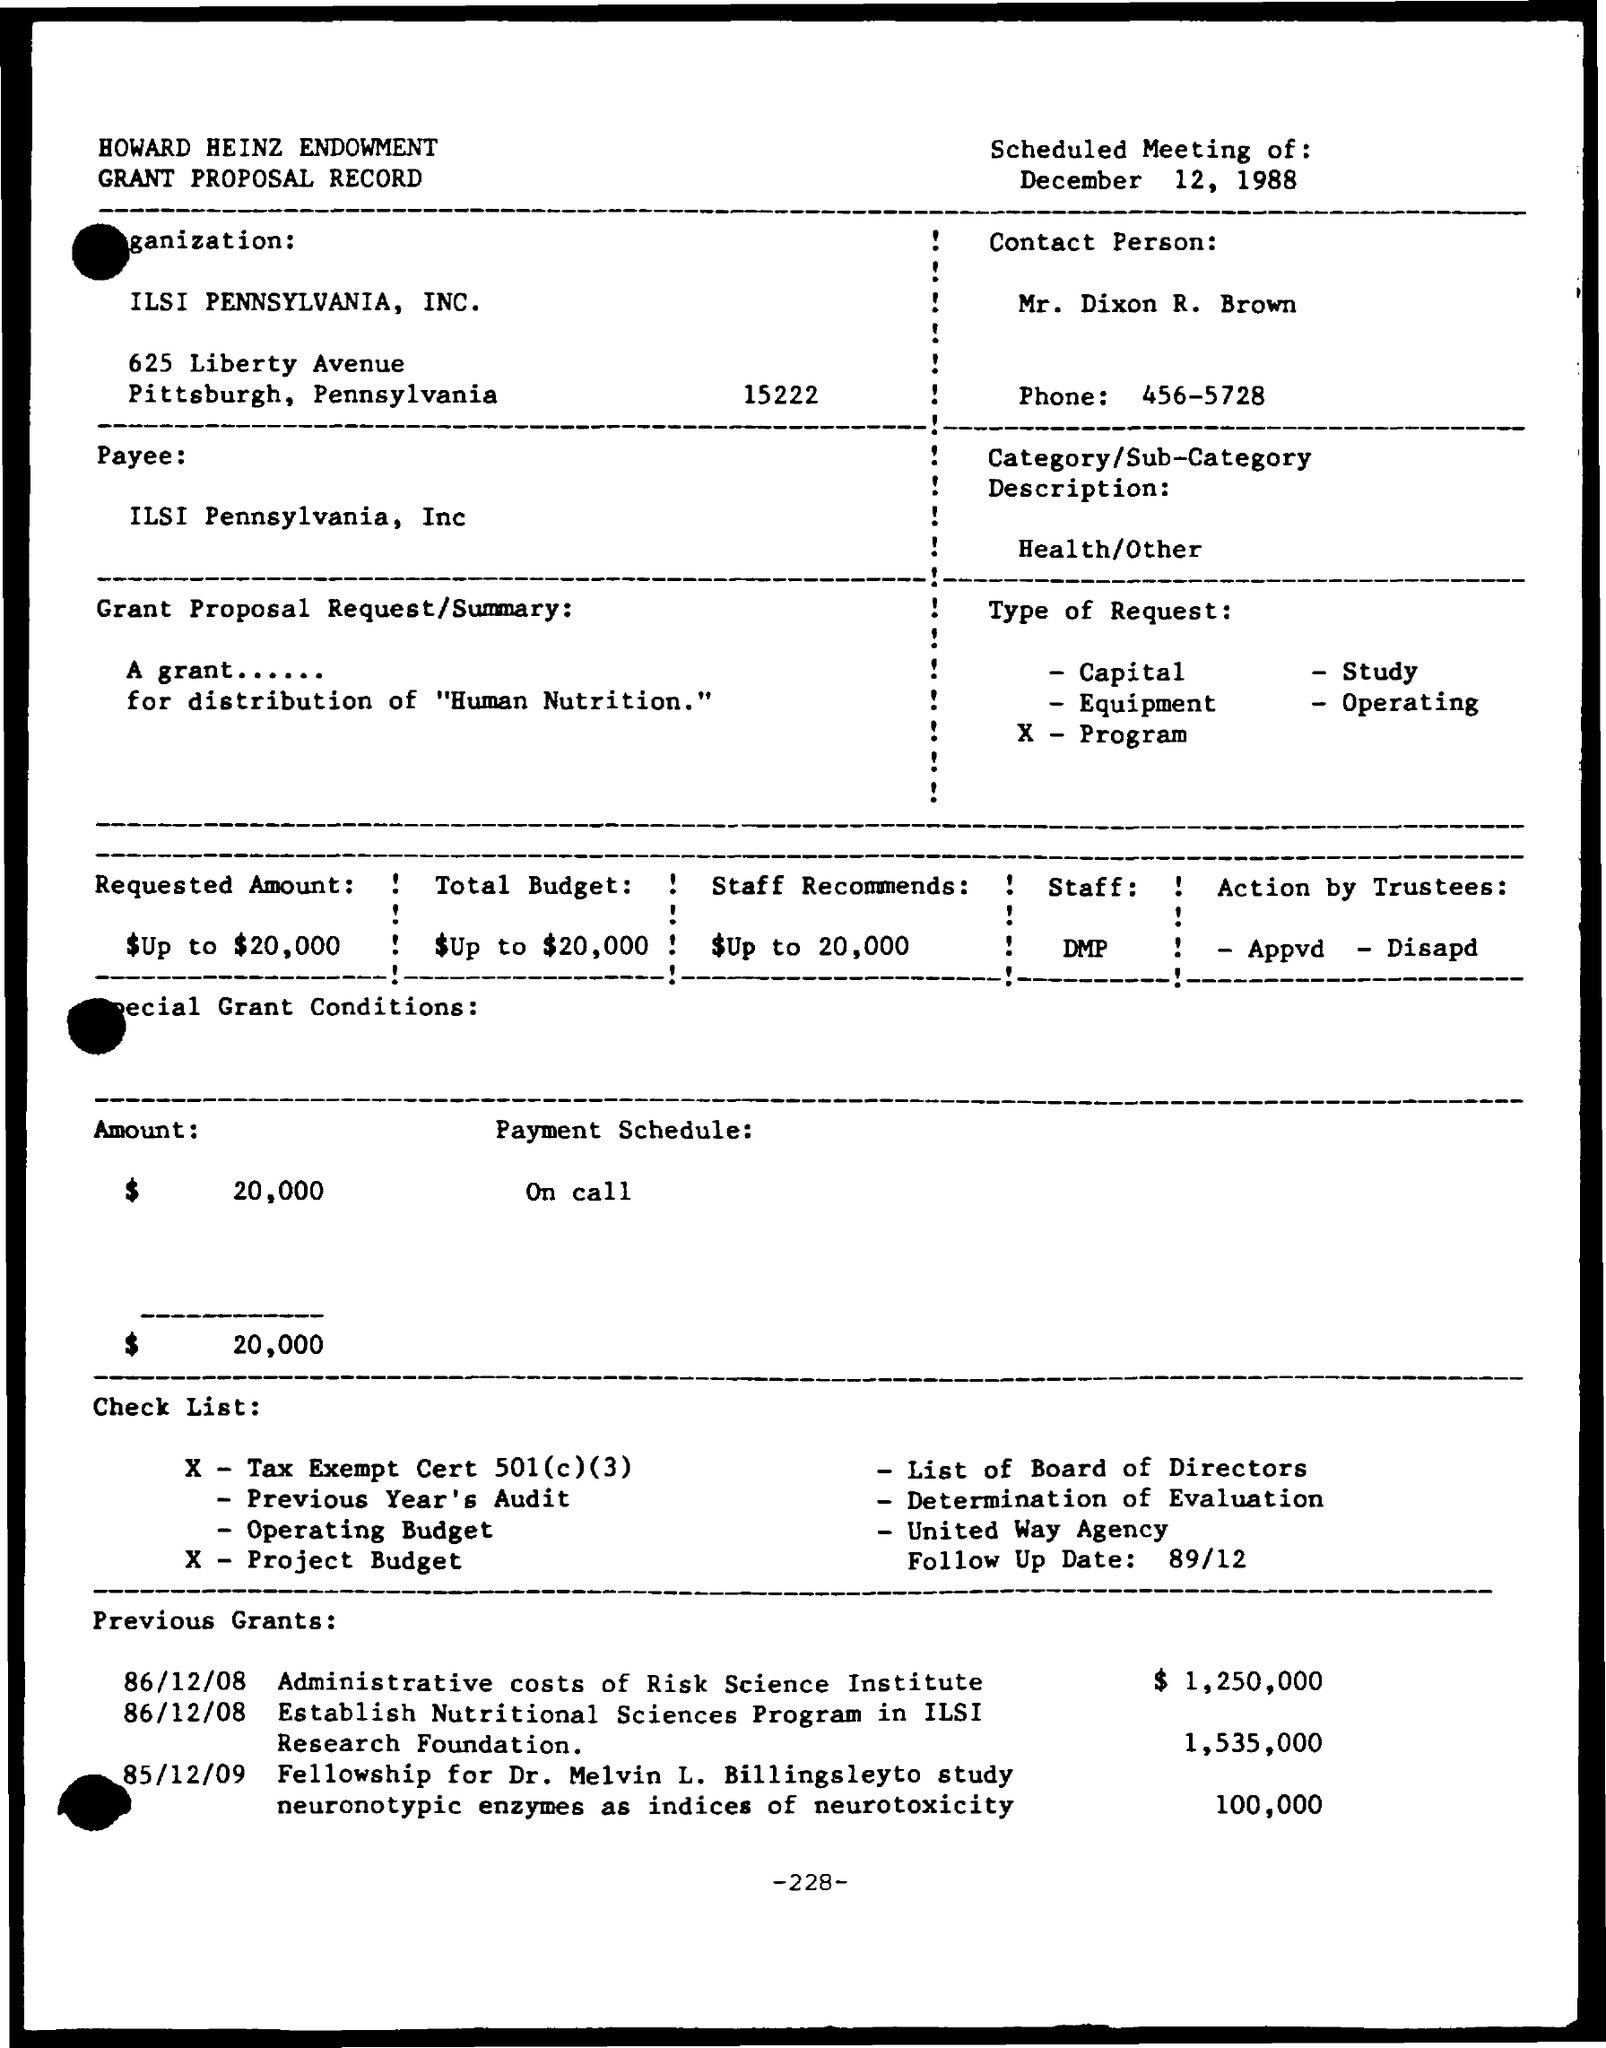Outline some significant characteristics in this image. The administrative costs of the Risk Science Institute are reported to be $1,250,000. The meeting is scheduled for December 12, 1988. The payment schedule is as follows: on call. The "What is the Category/Sub-Category Description? Health/Other" is a description that belongs to a category or subcategory, specifically in the field of health. ILSI Pennsylvania, Inc. is the organization. 